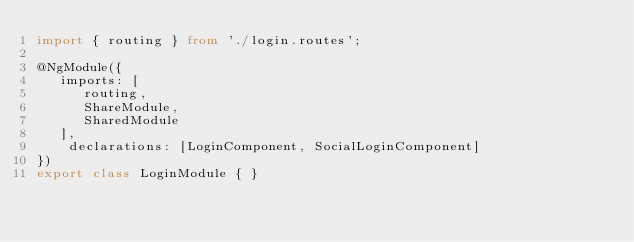<code> <loc_0><loc_0><loc_500><loc_500><_TypeScript_>import { routing } from './login.routes';

@NgModule({
   imports: [
      routing,
      ShareModule,
      SharedModule
   ],
    declarations: [LoginComponent, SocialLoginComponent]
})
export class LoginModule { }
</code> 